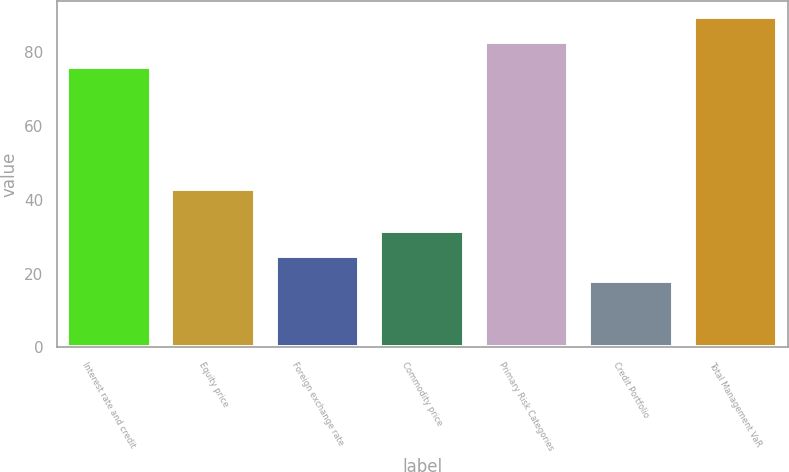<chart> <loc_0><loc_0><loc_500><loc_500><bar_chart><fcel>Interest rate and credit<fcel>Equity price<fcel>Foreign exchange rate<fcel>Commodity price<fcel>Primary Risk Categories<fcel>Credit Portfolio<fcel>Total Management VaR<nl><fcel>76<fcel>43<fcel>24.7<fcel>31.4<fcel>82.7<fcel>18<fcel>89.4<nl></chart> 